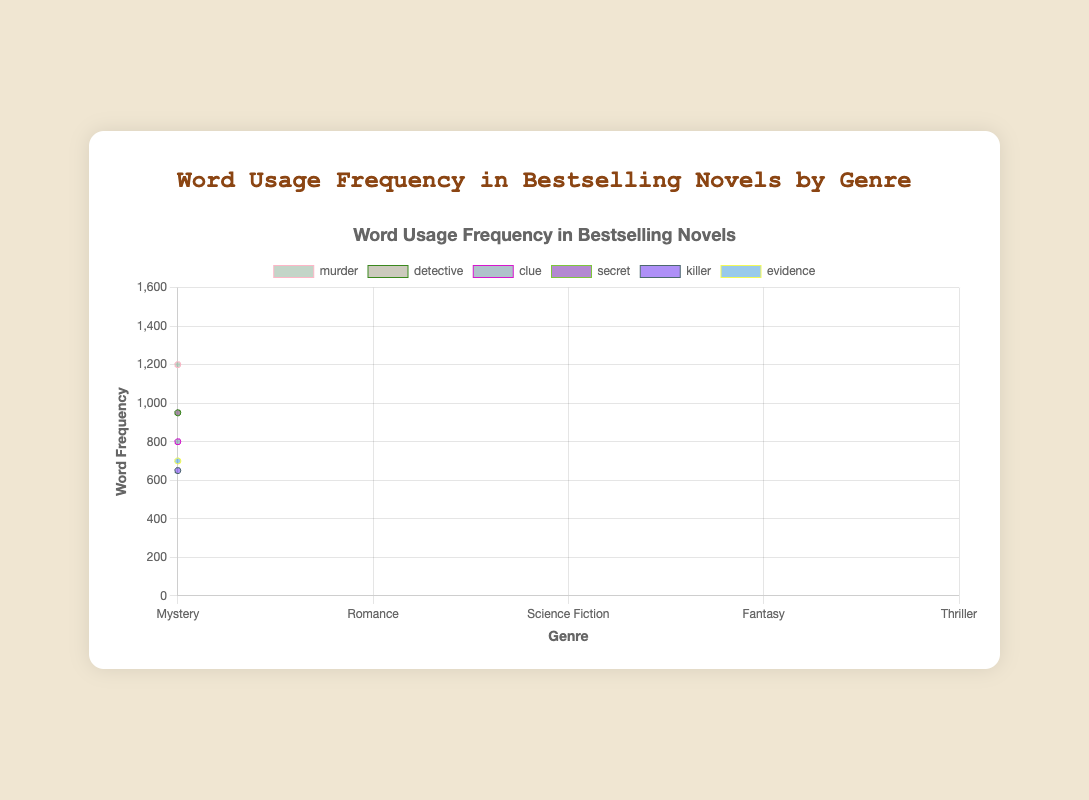What are the genres included in the figure? The figure represents word usage frequency in bestselling novels for the following genres: Mystery, Romance, Science Fiction, Fantasy, and Thriller. This information is displayed on the x-axis as the categories of word usage frequencies.
Answer: Mystery, Romance, Science Fiction, Fantasy, Thriller Which genre has the highest usage frequency of the word "love"? Looking at the area corresponding to the word "love" across all genres, the highest peak is seen under the Romance genre. The y-axis value reaches up to 1500 for "love" under Romance.
Answer: Romance What is the total word frequency for the word "future" across all genres? The figure shows the frequency of "future" in Science Fiction as 1000. Since "future" is shown in a unique data point under Science Fiction, this means 1000 is the total frequency.
Answer: 1000 Which word has the lowest frequency in the Mystery genre? Observing the segments of the chart for the Mystery genre, the word "killer" has the lowest frequency of 650.
Answer: killer How does the usage of the word "space" compare between Science Fiction and other genres? In the chart, the word "space" has significant usage in Science Fiction (1100). The visualization indicates negligible or no presence of this word in Mystery, Romance, Fantasy, and Thriller genres given the segments' heights are almost flat for these genres.
Answer: Highest in Science Fiction; minimal in others Which genre utilizes "magic" the most? By analyzing the regions for the word "magic," the preeminent area belongs to the Fantasy genre where the word usage reaches 1400.
Answer: Fantasy What word has the highest frequency across all genres? The highest frequency seen in the chart is for "love" under the Romance genre, which reaches up to 1500.
Answer: love What is the difference in the frequency of the word "quest" between the Fantasy and Thriller genres? The chart indicates the word "quest" has a frequency of 1100 in Fantasy, and it is not used in Thriller (frequency 0). The difference is 1100 - 0.
Answer: 1100 What word appears equally frequent in both the Mystery and Romance genres and what is its frequency? The word "secret" appears equally frequent in Mystery (950) and Romance (950), as seen by the length of the segments in both genres.
Answer: secret, 950 Which genre has the most uniform distribution of word frequencies, and how can it be identified? By visually inspecting the widths of the areas in each genre, Science Fiction exhibits more uniform heights for words like "alien," "space," "future," "robot," "technology," and "planet," indicating a more uniform distribution.
Answer: Science Fiction 